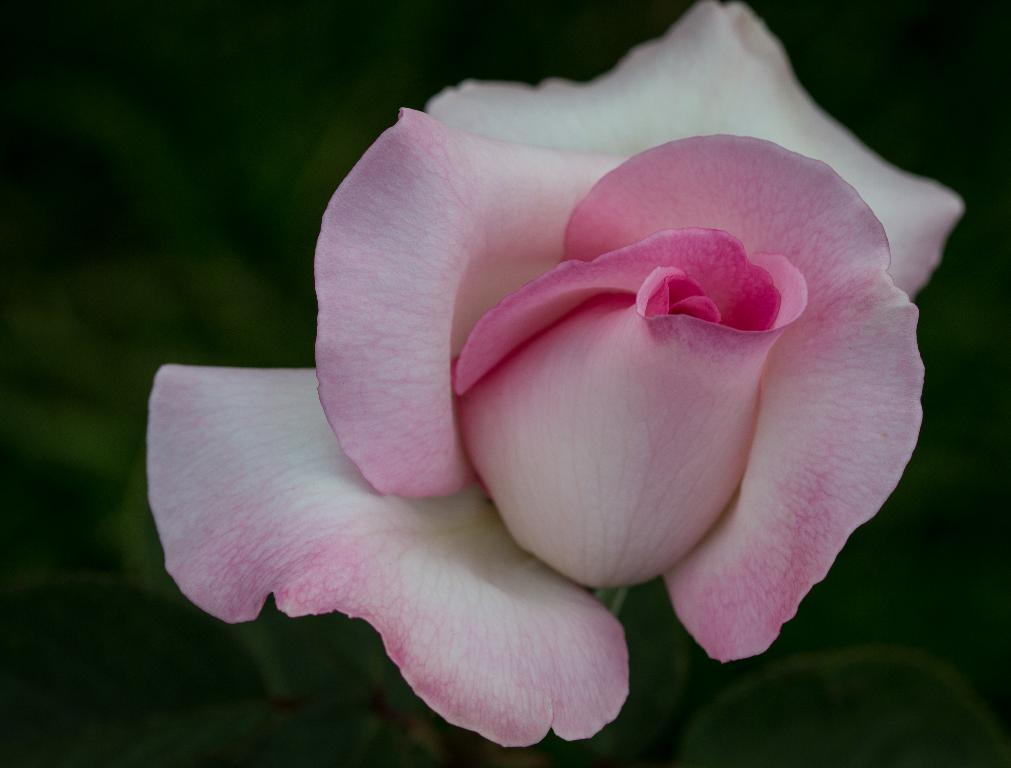What type of flower is in the image? There is a pink and white color rose in the image. Can you describe the background of the image? The background of the image is blurred. What type of relation does the spoon have with the rose in the image? There is no spoon present in the image, so there is no relation between the spoon and the rose. 